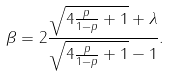Convert formula to latex. <formula><loc_0><loc_0><loc_500><loc_500>\beta = 2 \frac { \sqrt { 4 \frac { p } { 1 - p } + 1 } + \lambda } { \sqrt { 4 \frac { p } { 1 - p } + 1 } - 1 } .</formula> 